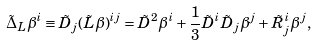<formula> <loc_0><loc_0><loc_500><loc_500>\tilde { \Delta } _ { L } \beta ^ { i } \equiv \tilde { D } _ { j } ( \tilde { L } \beta ) ^ { i j } = \tilde { D } ^ { 2 } \beta ^ { i } + \frac { 1 } { 3 } \tilde { D } ^ { i } \tilde { D } _ { j } \beta ^ { j } + \tilde { R } ^ { i } _ { j } \beta ^ { j } ,</formula> 